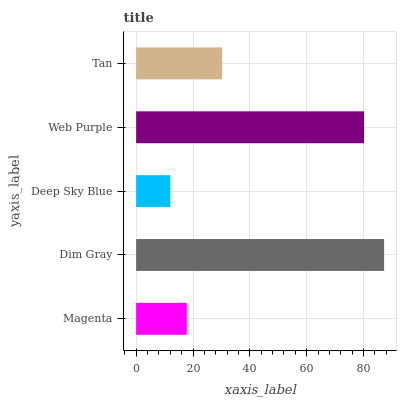Is Deep Sky Blue the minimum?
Answer yes or no. Yes. Is Dim Gray the maximum?
Answer yes or no. Yes. Is Dim Gray the minimum?
Answer yes or no. No. Is Deep Sky Blue the maximum?
Answer yes or no. No. Is Dim Gray greater than Deep Sky Blue?
Answer yes or no. Yes. Is Deep Sky Blue less than Dim Gray?
Answer yes or no. Yes. Is Deep Sky Blue greater than Dim Gray?
Answer yes or no. No. Is Dim Gray less than Deep Sky Blue?
Answer yes or no. No. Is Tan the high median?
Answer yes or no. Yes. Is Tan the low median?
Answer yes or no. Yes. Is Web Purple the high median?
Answer yes or no. No. Is Magenta the low median?
Answer yes or no. No. 